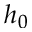Convert formula to latex. <formula><loc_0><loc_0><loc_500><loc_500>h _ { 0 }</formula> 